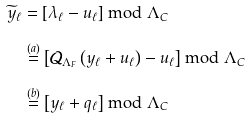Convert formula to latex. <formula><loc_0><loc_0><loc_500><loc_500>\widetilde { y } _ { \ell } & = \left [ \lambda _ { \ell } - u _ { \ell } \right ] \bmod \Lambda _ { C } \\ & \stackrel { ( a ) } { = } \left [ \mathcal { Q } _ { \Lambda _ { F } } \left ( { y } _ { \ell } + u _ { \ell } \right ) - u _ { \ell } \right ] \bmod \Lambda _ { C } \\ & \stackrel { ( b ) } { = } \left [ { y } _ { \ell } + { q } _ { \ell } \right ] \bmod \Lambda _ { C }</formula> 